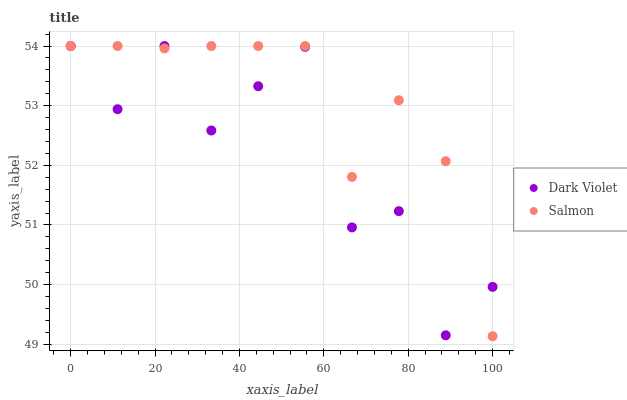Does Dark Violet have the minimum area under the curve?
Answer yes or no. Yes. Does Salmon have the maximum area under the curve?
Answer yes or no. Yes. Does Dark Violet have the maximum area under the curve?
Answer yes or no. No. Is Salmon the smoothest?
Answer yes or no. Yes. Is Dark Violet the roughest?
Answer yes or no. Yes. Is Dark Violet the smoothest?
Answer yes or no. No. Does Salmon have the lowest value?
Answer yes or no. Yes. Does Dark Violet have the lowest value?
Answer yes or no. No. Does Dark Violet have the highest value?
Answer yes or no. Yes. Does Salmon intersect Dark Violet?
Answer yes or no. Yes. Is Salmon less than Dark Violet?
Answer yes or no. No. Is Salmon greater than Dark Violet?
Answer yes or no. No. 